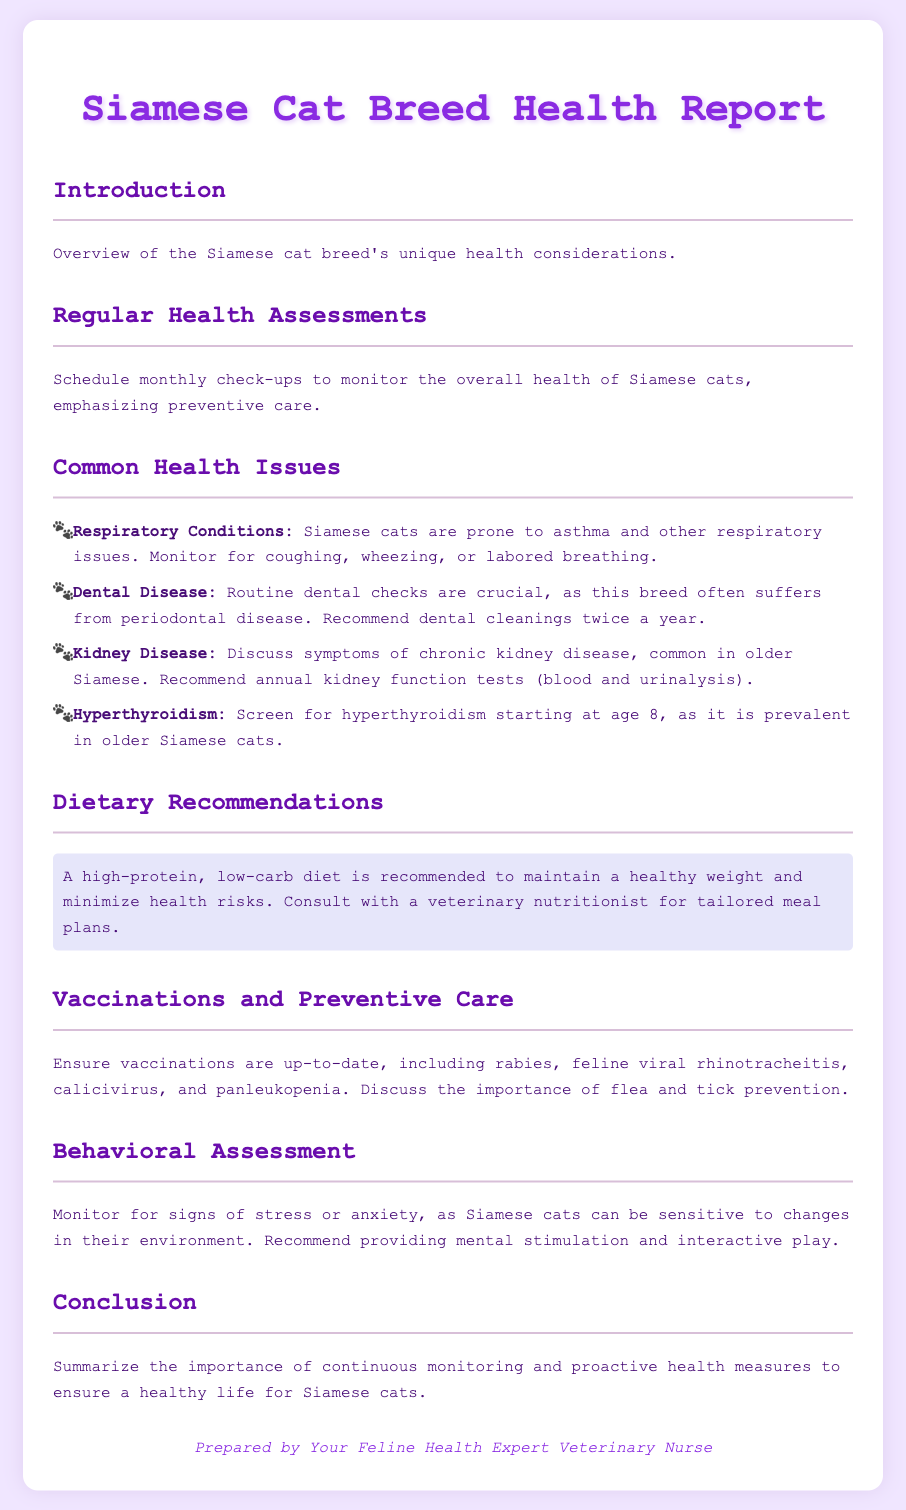what is the primary focus of the health report? The primary focus of the health report is the unique health considerations of the Siamese cat breed.
Answer: unique health considerations how often should Siamese cats have check-ups? The document recommends scheduling monthly check-ups to monitor the overall health.
Answer: monthly what are the common respiratory conditions in Siamese cats? According to the document, Siamese cats are prone to asthma and other respiratory issues.
Answer: asthma at what age should Siamese cats be screened for hyperthyroidism? The report suggests screening for hyperthyroidism starting at age 8.
Answer: age 8 what dietary recommendation is given for Siamese cats? The report recommends a high-protein, low-carb diet to maintain health.
Answer: high-protein, low-carb diet how often should dental cleanings be performed? It is recommended to have dental cleanings twice a year for Siamese cats.
Answer: twice a year what is a recommended preventive care measure for Siamese cats? The document stresses ensuring vaccinations are up-to-date as a preventive measure.
Answer: up-to-date vaccinations what should be monitored in Siamese cats for behavioral health? The report advises monitoring for signs of stress or anxiety.
Answer: signs of stress or anxiety 